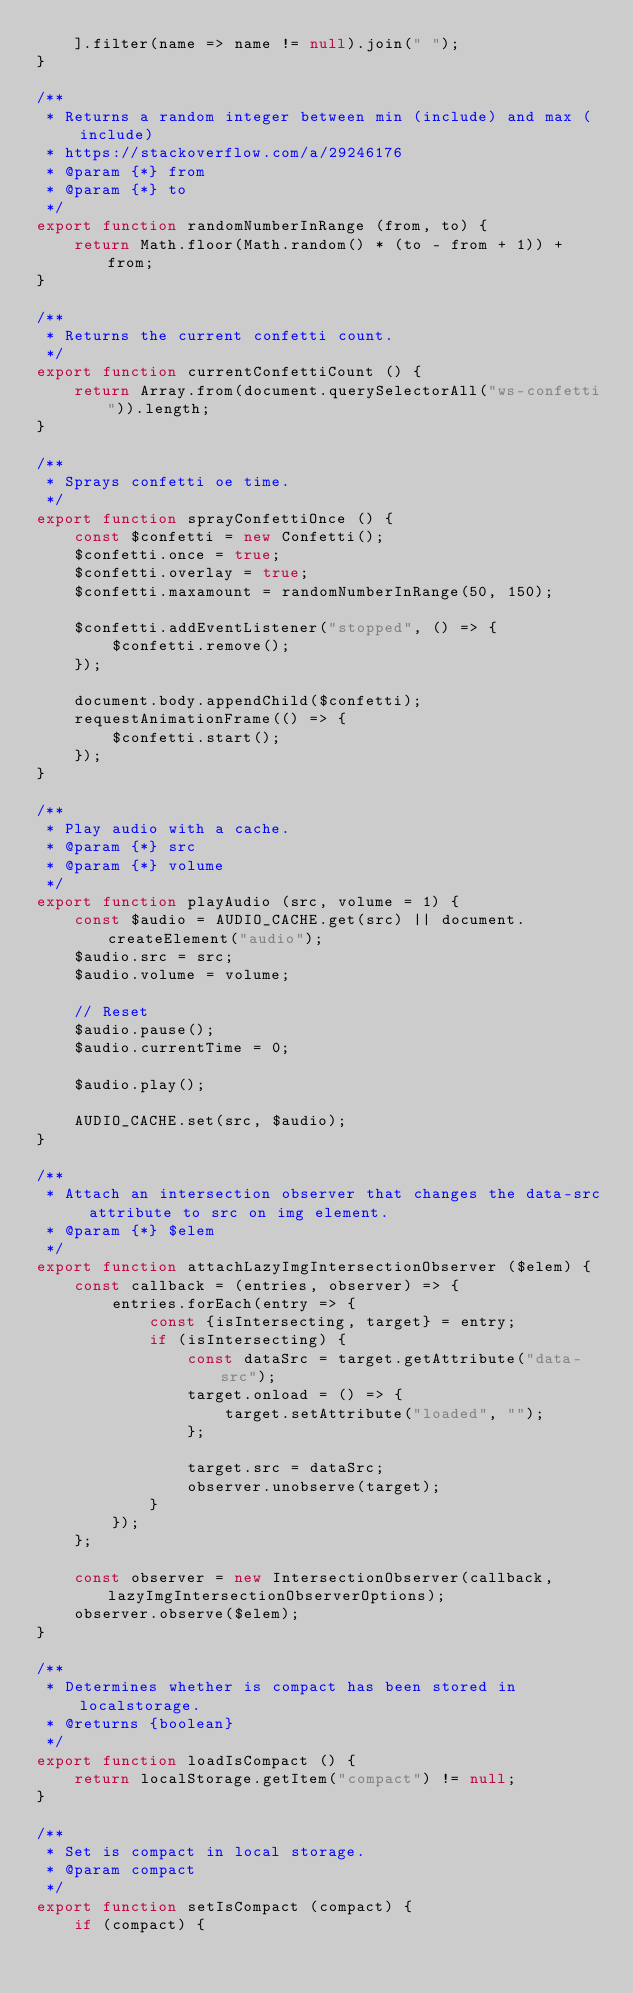Convert code to text. <code><loc_0><loc_0><loc_500><loc_500><_JavaScript_>	].filter(name => name != null).join(" ");
}

/**
 * Returns a random integer between min (include) and max (include)
 * https://stackoverflow.com/a/29246176
 * @param {*} from
 * @param {*} to
 */
export function randomNumberInRange (from, to) {
	return Math.floor(Math.random() * (to - from + 1)) + from;
}

/**
 * Returns the current confetti count.
 */
export function currentConfettiCount () {
	return Array.from(document.querySelectorAll("ws-confetti")).length;
}

/**
 * Sprays confetti oe time.
 */
export function sprayConfettiOnce () {
	const $confetti = new Confetti();
	$confetti.once = true;
	$confetti.overlay = true;
	$confetti.maxamount = randomNumberInRange(50, 150);

	$confetti.addEventListener("stopped", () => {
		$confetti.remove();
	});

	document.body.appendChild($confetti);
	requestAnimationFrame(() => {
		$confetti.start();
	});
}

/**
 * Play audio with a cache.
 * @param {*} src
 * @param {*} volume
 */
export function playAudio (src, volume = 1) {
	const $audio = AUDIO_CACHE.get(src) || document.createElement("audio");
	$audio.src = src;
	$audio.volume = volume;

	// Reset
	$audio.pause();
	$audio.currentTime = 0;

	$audio.play();

	AUDIO_CACHE.set(src, $audio);
}

/**
 * Attach an intersection observer that changes the data-src attribute to src on img element.
 * @param {*} $elem
 */
export function attachLazyImgIntersectionObserver ($elem) {
	const callback = (entries, observer) => {
		entries.forEach(entry => {
			const {isIntersecting, target} = entry;
			if (isIntersecting) {
				const dataSrc = target.getAttribute("data-src");
				target.onload = () => {
					target.setAttribute("loaded", "");
				};

				target.src = dataSrc;
				observer.unobserve(target);
			}
		});
	};

	const observer = new IntersectionObserver(callback, lazyImgIntersectionObserverOptions);
	observer.observe($elem);
}

/**
 * Determines whether is compact has been stored in localstorage.
 * @returns {boolean}
 */
export function loadIsCompact () {
	return localStorage.getItem("compact") != null;
}

/**
 * Set is compact in local storage.
 * @param compact
 */
export function setIsCompact (compact) {
	if (compact) {</code> 